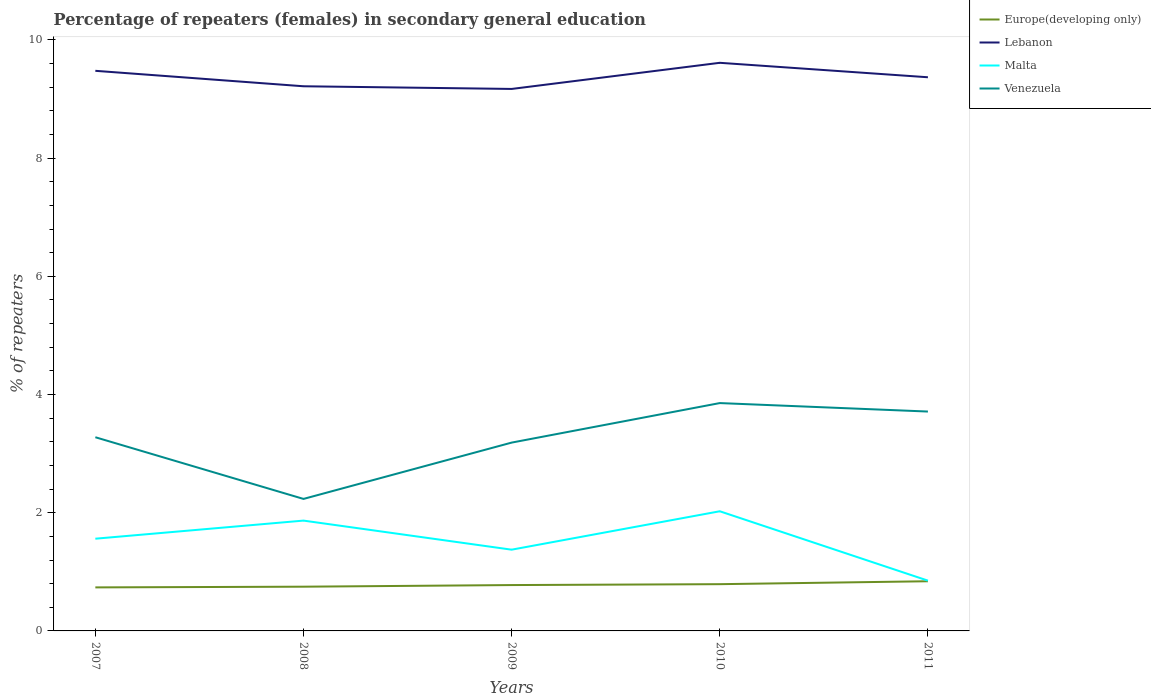Does the line corresponding to Lebanon intersect with the line corresponding to Venezuela?
Keep it short and to the point. No. Is the number of lines equal to the number of legend labels?
Your answer should be compact. Yes. Across all years, what is the maximum percentage of female repeaters in Europe(developing only)?
Your answer should be compact. 0.74. In which year was the percentage of female repeaters in Venezuela maximum?
Your answer should be compact. 2008. What is the total percentage of female repeaters in Europe(developing only) in the graph?
Your answer should be very brief. -0.05. What is the difference between the highest and the second highest percentage of female repeaters in Europe(developing only)?
Your answer should be compact. 0.1. What is the difference between the highest and the lowest percentage of female repeaters in Malta?
Your answer should be compact. 3. Is the percentage of female repeaters in Lebanon strictly greater than the percentage of female repeaters in Venezuela over the years?
Offer a very short reply. No. How many years are there in the graph?
Your answer should be compact. 5. Does the graph contain any zero values?
Provide a short and direct response. No. Does the graph contain grids?
Offer a terse response. No. Where does the legend appear in the graph?
Offer a terse response. Top right. How many legend labels are there?
Your response must be concise. 4. What is the title of the graph?
Your answer should be compact. Percentage of repeaters (females) in secondary general education. What is the label or title of the Y-axis?
Make the answer very short. % of repeaters. What is the % of repeaters of Europe(developing only) in 2007?
Offer a terse response. 0.74. What is the % of repeaters in Lebanon in 2007?
Offer a terse response. 9.48. What is the % of repeaters in Malta in 2007?
Make the answer very short. 1.56. What is the % of repeaters of Venezuela in 2007?
Offer a very short reply. 3.28. What is the % of repeaters of Europe(developing only) in 2008?
Offer a very short reply. 0.75. What is the % of repeaters of Lebanon in 2008?
Give a very brief answer. 9.22. What is the % of repeaters in Malta in 2008?
Ensure brevity in your answer.  1.87. What is the % of repeaters of Venezuela in 2008?
Give a very brief answer. 2.23. What is the % of repeaters in Europe(developing only) in 2009?
Your answer should be compact. 0.78. What is the % of repeaters of Lebanon in 2009?
Keep it short and to the point. 9.17. What is the % of repeaters of Malta in 2009?
Your answer should be very brief. 1.37. What is the % of repeaters in Venezuela in 2009?
Make the answer very short. 3.19. What is the % of repeaters of Europe(developing only) in 2010?
Offer a terse response. 0.79. What is the % of repeaters of Lebanon in 2010?
Provide a short and direct response. 9.61. What is the % of repeaters of Malta in 2010?
Your response must be concise. 2.02. What is the % of repeaters in Venezuela in 2010?
Keep it short and to the point. 3.86. What is the % of repeaters in Europe(developing only) in 2011?
Keep it short and to the point. 0.84. What is the % of repeaters of Lebanon in 2011?
Your response must be concise. 9.37. What is the % of repeaters in Malta in 2011?
Offer a terse response. 0.85. What is the % of repeaters of Venezuela in 2011?
Your answer should be very brief. 3.71. Across all years, what is the maximum % of repeaters of Europe(developing only)?
Ensure brevity in your answer.  0.84. Across all years, what is the maximum % of repeaters in Lebanon?
Provide a short and direct response. 9.61. Across all years, what is the maximum % of repeaters in Malta?
Give a very brief answer. 2.02. Across all years, what is the maximum % of repeaters of Venezuela?
Provide a succinct answer. 3.86. Across all years, what is the minimum % of repeaters in Europe(developing only)?
Your response must be concise. 0.74. Across all years, what is the minimum % of repeaters in Lebanon?
Provide a short and direct response. 9.17. Across all years, what is the minimum % of repeaters of Malta?
Offer a very short reply. 0.85. Across all years, what is the minimum % of repeaters of Venezuela?
Provide a succinct answer. 2.23. What is the total % of repeaters of Europe(developing only) in the graph?
Make the answer very short. 3.89. What is the total % of repeaters of Lebanon in the graph?
Give a very brief answer. 46.85. What is the total % of repeaters of Malta in the graph?
Offer a terse response. 7.68. What is the total % of repeaters of Venezuela in the graph?
Provide a short and direct response. 16.27. What is the difference between the % of repeaters in Europe(developing only) in 2007 and that in 2008?
Your answer should be very brief. -0.01. What is the difference between the % of repeaters in Lebanon in 2007 and that in 2008?
Your answer should be compact. 0.26. What is the difference between the % of repeaters in Malta in 2007 and that in 2008?
Make the answer very short. -0.31. What is the difference between the % of repeaters of Venezuela in 2007 and that in 2008?
Your answer should be very brief. 1.04. What is the difference between the % of repeaters of Europe(developing only) in 2007 and that in 2009?
Make the answer very short. -0.04. What is the difference between the % of repeaters in Lebanon in 2007 and that in 2009?
Ensure brevity in your answer.  0.31. What is the difference between the % of repeaters of Malta in 2007 and that in 2009?
Offer a terse response. 0.19. What is the difference between the % of repeaters in Venezuela in 2007 and that in 2009?
Give a very brief answer. 0.09. What is the difference between the % of repeaters in Europe(developing only) in 2007 and that in 2010?
Provide a succinct answer. -0.05. What is the difference between the % of repeaters in Lebanon in 2007 and that in 2010?
Ensure brevity in your answer.  -0.14. What is the difference between the % of repeaters in Malta in 2007 and that in 2010?
Provide a succinct answer. -0.46. What is the difference between the % of repeaters of Venezuela in 2007 and that in 2010?
Your answer should be very brief. -0.58. What is the difference between the % of repeaters in Europe(developing only) in 2007 and that in 2011?
Provide a short and direct response. -0.1. What is the difference between the % of repeaters in Lebanon in 2007 and that in 2011?
Your response must be concise. 0.11. What is the difference between the % of repeaters of Malta in 2007 and that in 2011?
Keep it short and to the point. 0.71. What is the difference between the % of repeaters in Venezuela in 2007 and that in 2011?
Ensure brevity in your answer.  -0.43. What is the difference between the % of repeaters in Europe(developing only) in 2008 and that in 2009?
Keep it short and to the point. -0.03. What is the difference between the % of repeaters in Lebanon in 2008 and that in 2009?
Make the answer very short. 0.05. What is the difference between the % of repeaters in Malta in 2008 and that in 2009?
Make the answer very short. 0.49. What is the difference between the % of repeaters in Venezuela in 2008 and that in 2009?
Make the answer very short. -0.95. What is the difference between the % of repeaters of Europe(developing only) in 2008 and that in 2010?
Your answer should be very brief. -0.04. What is the difference between the % of repeaters of Lebanon in 2008 and that in 2010?
Your answer should be very brief. -0.4. What is the difference between the % of repeaters of Malta in 2008 and that in 2010?
Keep it short and to the point. -0.16. What is the difference between the % of repeaters in Venezuela in 2008 and that in 2010?
Provide a short and direct response. -1.62. What is the difference between the % of repeaters of Europe(developing only) in 2008 and that in 2011?
Give a very brief answer. -0.09. What is the difference between the % of repeaters in Lebanon in 2008 and that in 2011?
Your response must be concise. -0.15. What is the difference between the % of repeaters in Malta in 2008 and that in 2011?
Offer a very short reply. 1.02. What is the difference between the % of repeaters in Venezuela in 2008 and that in 2011?
Provide a succinct answer. -1.48. What is the difference between the % of repeaters of Europe(developing only) in 2009 and that in 2010?
Your response must be concise. -0.02. What is the difference between the % of repeaters in Lebanon in 2009 and that in 2010?
Your answer should be compact. -0.44. What is the difference between the % of repeaters in Malta in 2009 and that in 2010?
Ensure brevity in your answer.  -0.65. What is the difference between the % of repeaters of Venezuela in 2009 and that in 2010?
Your answer should be very brief. -0.67. What is the difference between the % of repeaters of Europe(developing only) in 2009 and that in 2011?
Your answer should be very brief. -0.06. What is the difference between the % of repeaters in Lebanon in 2009 and that in 2011?
Ensure brevity in your answer.  -0.2. What is the difference between the % of repeaters of Malta in 2009 and that in 2011?
Your answer should be very brief. 0.52. What is the difference between the % of repeaters of Venezuela in 2009 and that in 2011?
Make the answer very short. -0.53. What is the difference between the % of repeaters of Europe(developing only) in 2010 and that in 2011?
Provide a short and direct response. -0.05. What is the difference between the % of repeaters of Lebanon in 2010 and that in 2011?
Offer a very short reply. 0.24. What is the difference between the % of repeaters of Malta in 2010 and that in 2011?
Your answer should be very brief. 1.17. What is the difference between the % of repeaters in Venezuela in 2010 and that in 2011?
Your response must be concise. 0.14. What is the difference between the % of repeaters of Europe(developing only) in 2007 and the % of repeaters of Lebanon in 2008?
Make the answer very short. -8.48. What is the difference between the % of repeaters in Europe(developing only) in 2007 and the % of repeaters in Malta in 2008?
Offer a very short reply. -1.13. What is the difference between the % of repeaters of Europe(developing only) in 2007 and the % of repeaters of Venezuela in 2008?
Offer a terse response. -1.5. What is the difference between the % of repeaters of Lebanon in 2007 and the % of repeaters of Malta in 2008?
Your response must be concise. 7.61. What is the difference between the % of repeaters of Lebanon in 2007 and the % of repeaters of Venezuela in 2008?
Your answer should be very brief. 7.24. What is the difference between the % of repeaters of Malta in 2007 and the % of repeaters of Venezuela in 2008?
Offer a terse response. -0.67. What is the difference between the % of repeaters in Europe(developing only) in 2007 and the % of repeaters in Lebanon in 2009?
Provide a short and direct response. -8.43. What is the difference between the % of repeaters of Europe(developing only) in 2007 and the % of repeaters of Malta in 2009?
Provide a succinct answer. -0.64. What is the difference between the % of repeaters in Europe(developing only) in 2007 and the % of repeaters in Venezuela in 2009?
Give a very brief answer. -2.45. What is the difference between the % of repeaters in Lebanon in 2007 and the % of repeaters in Malta in 2009?
Offer a terse response. 8.1. What is the difference between the % of repeaters in Lebanon in 2007 and the % of repeaters in Venezuela in 2009?
Your answer should be very brief. 6.29. What is the difference between the % of repeaters of Malta in 2007 and the % of repeaters of Venezuela in 2009?
Give a very brief answer. -1.63. What is the difference between the % of repeaters in Europe(developing only) in 2007 and the % of repeaters in Lebanon in 2010?
Keep it short and to the point. -8.88. What is the difference between the % of repeaters of Europe(developing only) in 2007 and the % of repeaters of Malta in 2010?
Provide a succinct answer. -1.29. What is the difference between the % of repeaters in Europe(developing only) in 2007 and the % of repeaters in Venezuela in 2010?
Give a very brief answer. -3.12. What is the difference between the % of repeaters of Lebanon in 2007 and the % of repeaters of Malta in 2010?
Your response must be concise. 7.45. What is the difference between the % of repeaters in Lebanon in 2007 and the % of repeaters in Venezuela in 2010?
Your answer should be compact. 5.62. What is the difference between the % of repeaters of Malta in 2007 and the % of repeaters of Venezuela in 2010?
Your response must be concise. -2.3. What is the difference between the % of repeaters of Europe(developing only) in 2007 and the % of repeaters of Lebanon in 2011?
Ensure brevity in your answer.  -8.63. What is the difference between the % of repeaters of Europe(developing only) in 2007 and the % of repeaters of Malta in 2011?
Your response must be concise. -0.11. What is the difference between the % of repeaters of Europe(developing only) in 2007 and the % of repeaters of Venezuela in 2011?
Offer a very short reply. -2.98. What is the difference between the % of repeaters of Lebanon in 2007 and the % of repeaters of Malta in 2011?
Your answer should be compact. 8.63. What is the difference between the % of repeaters in Lebanon in 2007 and the % of repeaters in Venezuela in 2011?
Offer a terse response. 5.77. What is the difference between the % of repeaters in Malta in 2007 and the % of repeaters in Venezuela in 2011?
Offer a terse response. -2.15. What is the difference between the % of repeaters in Europe(developing only) in 2008 and the % of repeaters in Lebanon in 2009?
Your answer should be very brief. -8.42. What is the difference between the % of repeaters in Europe(developing only) in 2008 and the % of repeaters in Malta in 2009?
Offer a very short reply. -0.63. What is the difference between the % of repeaters of Europe(developing only) in 2008 and the % of repeaters of Venezuela in 2009?
Provide a succinct answer. -2.44. What is the difference between the % of repeaters of Lebanon in 2008 and the % of repeaters of Malta in 2009?
Provide a short and direct response. 7.84. What is the difference between the % of repeaters of Lebanon in 2008 and the % of repeaters of Venezuela in 2009?
Offer a very short reply. 6.03. What is the difference between the % of repeaters in Malta in 2008 and the % of repeaters in Venezuela in 2009?
Your response must be concise. -1.32. What is the difference between the % of repeaters of Europe(developing only) in 2008 and the % of repeaters of Lebanon in 2010?
Provide a succinct answer. -8.87. What is the difference between the % of repeaters in Europe(developing only) in 2008 and the % of repeaters in Malta in 2010?
Provide a short and direct response. -1.28. What is the difference between the % of repeaters in Europe(developing only) in 2008 and the % of repeaters in Venezuela in 2010?
Your response must be concise. -3.11. What is the difference between the % of repeaters in Lebanon in 2008 and the % of repeaters in Malta in 2010?
Make the answer very short. 7.19. What is the difference between the % of repeaters of Lebanon in 2008 and the % of repeaters of Venezuela in 2010?
Your answer should be compact. 5.36. What is the difference between the % of repeaters in Malta in 2008 and the % of repeaters in Venezuela in 2010?
Your answer should be compact. -1.99. What is the difference between the % of repeaters of Europe(developing only) in 2008 and the % of repeaters of Lebanon in 2011?
Your answer should be very brief. -8.62. What is the difference between the % of repeaters of Europe(developing only) in 2008 and the % of repeaters of Malta in 2011?
Offer a terse response. -0.1. What is the difference between the % of repeaters in Europe(developing only) in 2008 and the % of repeaters in Venezuela in 2011?
Offer a very short reply. -2.96. What is the difference between the % of repeaters of Lebanon in 2008 and the % of repeaters of Malta in 2011?
Your answer should be compact. 8.37. What is the difference between the % of repeaters in Lebanon in 2008 and the % of repeaters in Venezuela in 2011?
Make the answer very short. 5.5. What is the difference between the % of repeaters in Malta in 2008 and the % of repeaters in Venezuela in 2011?
Keep it short and to the point. -1.85. What is the difference between the % of repeaters in Europe(developing only) in 2009 and the % of repeaters in Lebanon in 2010?
Your answer should be compact. -8.84. What is the difference between the % of repeaters of Europe(developing only) in 2009 and the % of repeaters of Malta in 2010?
Ensure brevity in your answer.  -1.25. What is the difference between the % of repeaters in Europe(developing only) in 2009 and the % of repeaters in Venezuela in 2010?
Offer a very short reply. -3.08. What is the difference between the % of repeaters in Lebanon in 2009 and the % of repeaters in Malta in 2010?
Provide a short and direct response. 7.15. What is the difference between the % of repeaters of Lebanon in 2009 and the % of repeaters of Venezuela in 2010?
Your answer should be compact. 5.32. What is the difference between the % of repeaters in Malta in 2009 and the % of repeaters in Venezuela in 2010?
Make the answer very short. -2.48. What is the difference between the % of repeaters of Europe(developing only) in 2009 and the % of repeaters of Lebanon in 2011?
Ensure brevity in your answer.  -8.59. What is the difference between the % of repeaters in Europe(developing only) in 2009 and the % of repeaters in Malta in 2011?
Provide a succinct answer. -0.07. What is the difference between the % of repeaters of Europe(developing only) in 2009 and the % of repeaters of Venezuela in 2011?
Ensure brevity in your answer.  -2.94. What is the difference between the % of repeaters in Lebanon in 2009 and the % of repeaters in Malta in 2011?
Offer a very short reply. 8.32. What is the difference between the % of repeaters in Lebanon in 2009 and the % of repeaters in Venezuela in 2011?
Your response must be concise. 5.46. What is the difference between the % of repeaters in Malta in 2009 and the % of repeaters in Venezuela in 2011?
Give a very brief answer. -2.34. What is the difference between the % of repeaters of Europe(developing only) in 2010 and the % of repeaters of Lebanon in 2011?
Your answer should be very brief. -8.58. What is the difference between the % of repeaters in Europe(developing only) in 2010 and the % of repeaters in Malta in 2011?
Provide a succinct answer. -0.06. What is the difference between the % of repeaters in Europe(developing only) in 2010 and the % of repeaters in Venezuela in 2011?
Provide a succinct answer. -2.92. What is the difference between the % of repeaters of Lebanon in 2010 and the % of repeaters of Malta in 2011?
Provide a succinct answer. 8.76. What is the difference between the % of repeaters in Lebanon in 2010 and the % of repeaters in Venezuela in 2011?
Your response must be concise. 5.9. What is the difference between the % of repeaters in Malta in 2010 and the % of repeaters in Venezuela in 2011?
Offer a very short reply. -1.69. What is the average % of repeaters in Europe(developing only) per year?
Provide a succinct answer. 0.78. What is the average % of repeaters of Lebanon per year?
Offer a terse response. 9.37. What is the average % of repeaters in Malta per year?
Provide a short and direct response. 1.54. What is the average % of repeaters in Venezuela per year?
Provide a short and direct response. 3.25. In the year 2007, what is the difference between the % of repeaters in Europe(developing only) and % of repeaters in Lebanon?
Your answer should be compact. -8.74. In the year 2007, what is the difference between the % of repeaters of Europe(developing only) and % of repeaters of Malta?
Make the answer very short. -0.82. In the year 2007, what is the difference between the % of repeaters in Europe(developing only) and % of repeaters in Venezuela?
Offer a very short reply. -2.54. In the year 2007, what is the difference between the % of repeaters in Lebanon and % of repeaters in Malta?
Your answer should be very brief. 7.92. In the year 2007, what is the difference between the % of repeaters of Lebanon and % of repeaters of Venezuela?
Offer a terse response. 6.2. In the year 2007, what is the difference between the % of repeaters of Malta and % of repeaters of Venezuela?
Ensure brevity in your answer.  -1.72. In the year 2008, what is the difference between the % of repeaters in Europe(developing only) and % of repeaters in Lebanon?
Provide a succinct answer. -8.47. In the year 2008, what is the difference between the % of repeaters of Europe(developing only) and % of repeaters of Malta?
Your response must be concise. -1.12. In the year 2008, what is the difference between the % of repeaters in Europe(developing only) and % of repeaters in Venezuela?
Provide a succinct answer. -1.49. In the year 2008, what is the difference between the % of repeaters in Lebanon and % of repeaters in Malta?
Your answer should be compact. 7.35. In the year 2008, what is the difference between the % of repeaters of Lebanon and % of repeaters of Venezuela?
Your answer should be compact. 6.98. In the year 2008, what is the difference between the % of repeaters in Malta and % of repeaters in Venezuela?
Offer a very short reply. -0.37. In the year 2009, what is the difference between the % of repeaters in Europe(developing only) and % of repeaters in Lebanon?
Your response must be concise. -8.4. In the year 2009, what is the difference between the % of repeaters of Europe(developing only) and % of repeaters of Malta?
Offer a terse response. -0.6. In the year 2009, what is the difference between the % of repeaters in Europe(developing only) and % of repeaters in Venezuela?
Ensure brevity in your answer.  -2.41. In the year 2009, what is the difference between the % of repeaters in Lebanon and % of repeaters in Malta?
Keep it short and to the point. 7.8. In the year 2009, what is the difference between the % of repeaters in Lebanon and % of repeaters in Venezuela?
Provide a short and direct response. 5.98. In the year 2009, what is the difference between the % of repeaters of Malta and % of repeaters of Venezuela?
Ensure brevity in your answer.  -1.81. In the year 2010, what is the difference between the % of repeaters of Europe(developing only) and % of repeaters of Lebanon?
Your response must be concise. -8.82. In the year 2010, what is the difference between the % of repeaters in Europe(developing only) and % of repeaters in Malta?
Ensure brevity in your answer.  -1.23. In the year 2010, what is the difference between the % of repeaters in Europe(developing only) and % of repeaters in Venezuela?
Offer a very short reply. -3.06. In the year 2010, what is the difference between the % of repeaters in Lebanon and % of repeaters in Malta?
Keep it short and to the point. 7.59. In the year 2010, what is the difference between the % of repeaters in Lebanon and % of repeaters in Venezuela?
Offer a very short reply. 5.76. In the year 2010, what is the difference between the % of repeaters in Malta and % of repeaters in Venezuela?
Offer a very short reply. -1.83. In the year 2011, what is the difference between the % of repeaters in Europe(developing only) and % of repeaters in Lebanon?
Keep it short and to the point. -8.53. In the year 2011, what is the difference between the % of repeaters of Europe(developing only) and % of repeaters of Malta?
Your response must be concise. -0.01. In the year 2011, what is the difference between the % of repeaters of Europe(developing only) and % of repeaters of Venezuela?
Your answer should be compact. -2.87. In the year 2011, what is the difference between the % of repeaters in Lebanon and % of repeaters in Malta?
Keep it short and to the point. 8.52. In the year 2011, what is the difference between the % of repeaters of Lebanon and % of repeaters of Venezuela?
Give a very brief answer. 5.66. In the year 2011, what is the difference between the % of repeaters of Malta and % of repeaters of Venezuela?
Ensure brevity in your answer.  -2.86. What is the ratio of the % of repeaters in Europe(developing only) in 2007 to that in 2008?
Your answer should be very brief. 0.98. What is the ratio of the % of repeaters in Lebanon in 2007 to that in 2008?
Your answer should be very brief. 1.03. What is the ratio of the % of repeaters of Malta in 2007 to that in 2008?
Offer a terse response. 0.84. What is the ratio of the % of repeaters of Venezuela in 2007 to that in 2008?
Give a very brief answer. 1.47. What is the ratio of the % of repeaters in Europe(developing only) in 2007 to that in 2009?
Offer a terse response. 0.95. What is the ratio of the % of repeaters in Lebanon in 2007 to that in 2009?
Your answer should be compact. 1.03. What is the ratio of the % of repeaters of Malta in 2007 to that in 2009?
Offer a very short reply. 1.14. What is the ratio of the % of repeaters of Venezuela in 2007 to that in 2009?
Your answer should be very brief. 1.03. What is the ratio of the % of repeaters of Europe(developing only) in 2007 to that in 2010?
Provide a short and direct response. 0.93. What is the ratio of the % of repeaters of Lebanon in 2007 to that in 2010?
Offer a terse response. 0.99. What is the ratio of the % of repeaters in Malta in 2007 to that in 2010?
Offer a very short reply. 0.77. What is the ratio of the % of repeaters of Venezuela in 2007 to that in 2010?
Your response must be concise. 0.85. What is the ratio of the % of repeaters of Europe(developing only) in 2007 to that in 2011?
Offer a terse response. 0.88. What is the ratio of the % of repeaters in Lebanon in 2007 to that in 2011?
Your response must be concise. 1.01. What is the ratio of the % of repeaters in Malta in 2007 to that in 2011?
Make the answer very short. 1.83. What is the ratio of the % of repeaters in Venezuela in 2007 to that in 2011?
Provide a succinct answer. 0.88. What is the ratio of the % of repeaters of Europe(developing only) in 2008 to that in 2009?
Make the answer very short. 0.96. What is the ratio of the % of repeaters in Lebanon in 2008 to that in 2009?
Give a very brief answer. 1. What is the ratio of the % of repeaters of Malta in 2008 to that in 2009?
Your response must be concise. 1.36. What is the ratio of the % of repeaters of Venezuela in 2008 to that in 2009?
Provide a succinct answer. 0.7. What is the ratio of the % of repeaters of Europe(developing only) in 2008 to that in 2010?
Keep it short and to the point. 0.95. What is the ratio of the % of repeaters in Lebanon in 2008 to that in 2010?
Your response must be concise. 0.96. What is the ratio of the % of repeaters of Malta in 2008 to that in 2010?
Offer a terse response. 0.92. What is the ratio of the % of repeaters of Venezuela in 2008 to that in 2010?
Your answer should be very brief. 0.58. What is the ratio of the % of repeaters of Europe(developing only) in 2008 to that in 2011?
Your response must be concise. 0.89. What is the ratio of the % of repeaters in Lebanon in 2008 to that in 2011?
Keep it short and to the point. 0.98. What is the ratio of the % of repeaters of Malta in 2008 to that in 2011?
Your answer should be very brief. 2.19. What is the ratio of the % of repeaters in Venezuela in 2008 to that in 2011?
Offer a terse response. 0.6. What is the ratio of the % of repeaters of Europe(developing only) in 2009 to that in 2010?
Your response must be concise. 0.98. What is the ratio of the % of repeaters of Lebanon in 2009 to that in 2010?
Your answer should be compact. 0.95. What is the ratio of the % of repeaters of Malta in 2009 to that in 2010?
Your answer should be compact. 0.68. What is the ratio of the % of repeaters of Venezuela in 2009 to that in 2010?
Your response must be concise. 0.83. What is the ratio of the % of repeaters of Europe(developing only) in 2009 to that in 2011?
Your response must be concise. 0.92. What is the ratio of the % of repeaters in Lebanon in 2009 to that in 2011?
Your response must be concise. 0.98. What is the ratio of the % of repeaters in Malta in 2009 to that in 2011?
Make the answer very short. 1.62. What is the ratio of the % of repeaters in Venezuela in 2009 to that in 2011?
Ensure brevity in your answer.  0.86. What is the ratio of the % of repeaters in Europe(developing only) in 2010 to that in 2011?
Provide a short and direct response. 0.94. What is the ratio of the % of repeaters in Lebanon in 2010 to that in 2011?
Offer a terse response. 1.03. What is the ratio of the % of repeaters in Malta in 2010 to that in 2011?
Your answer should be very brief. 2.38. What is the ratio of the % of repeaters in Venezuela in 2010 to that in 2011?
Your answer should be very brief. 1.04. What is the difference between the highest and the second highest % of repeaters in Europe(developing only)?
Your response must be concise. 0.05. What is the difference between the highest and the second highest % of repeaters of Lebanon?
Keep it short and to the point. 0.14. What is the difference between the highest and the second highest % of repeaters of Malta?
Your response must be concise. 0.16. What is the difference between the highest and the second highest % of repeaters in Venezuela?
Ensure brevity in your answer.  0.14. What is the difference between the highest and the lowest % of repeaters in Europe(developing only)?
Keep it short and to the point. 0.1. What is the difference between the highest and the lowest % of repeaters of Lebanon?
Keep it short and to the point. 0.44. What is the difference between the highest and the lowest % of repeaters in Malta?
Keep it short and to the point. 1.17. What is the difference between the highest and the lowest % of repeaters in Venezuela?
Make the answer very short. 1.62. 